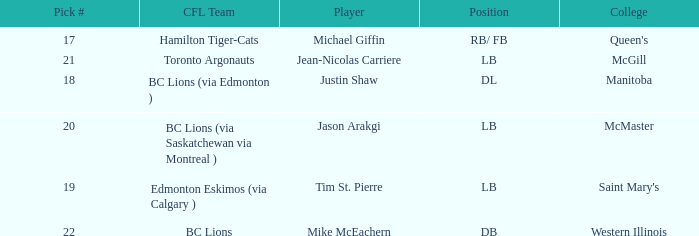What pick # did Western Illinois have? 22.0. 